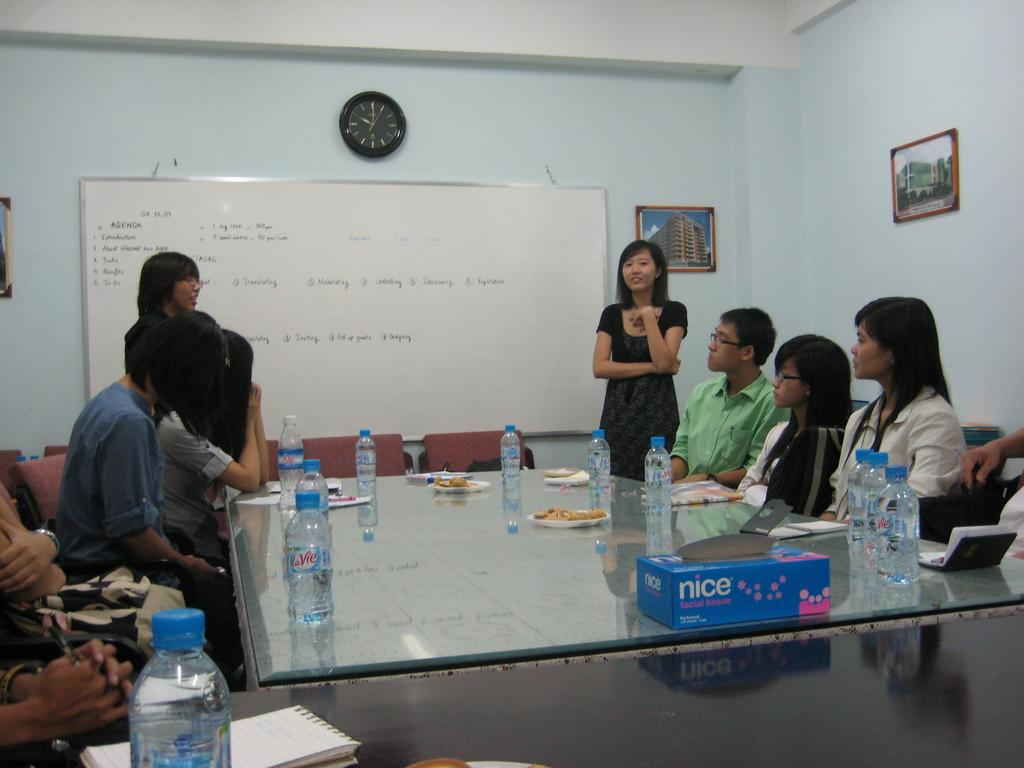<image>
Provide a brief description of the given image. A group of people sit around a table with nice facial tissues on it. 